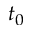Convert formula to latex. <formula><loc_0><loc_0><loc_500><loc_500>t _ { 0 }</formula> 